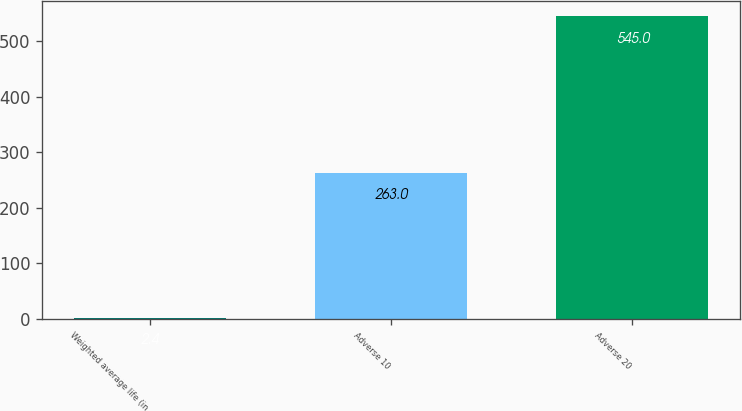Convert chart. <chart><loc_0><loc_0><loc_500><loc_500><bar_chart><fcel>Weighted average life (in<fcel>Adverse 10<fcel>Adverse 20<nl><fcel>2.4<fcel>263<fcel>545<nl></chart> 